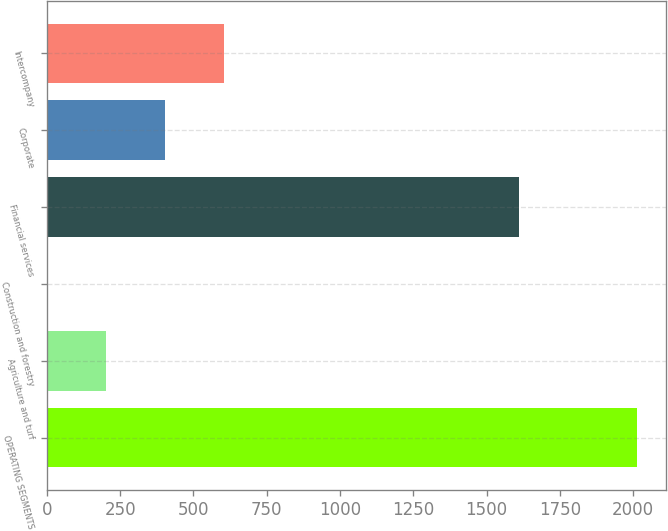Convert chart to OTSL. <chart><loc_0><loc_0><loc_500><loc_500><bar_chart><fcel>OPERATING SEGMENTS<fcel>Agriculture and turf<fcel>Construction and forestry<fcel>Financial services<fcel>Corporate<fcel>Intercompany<nl><fcel>2012<fcel>203<fcel>2<fcel>1610<fcel>404<fcel>605<nl></chart> 